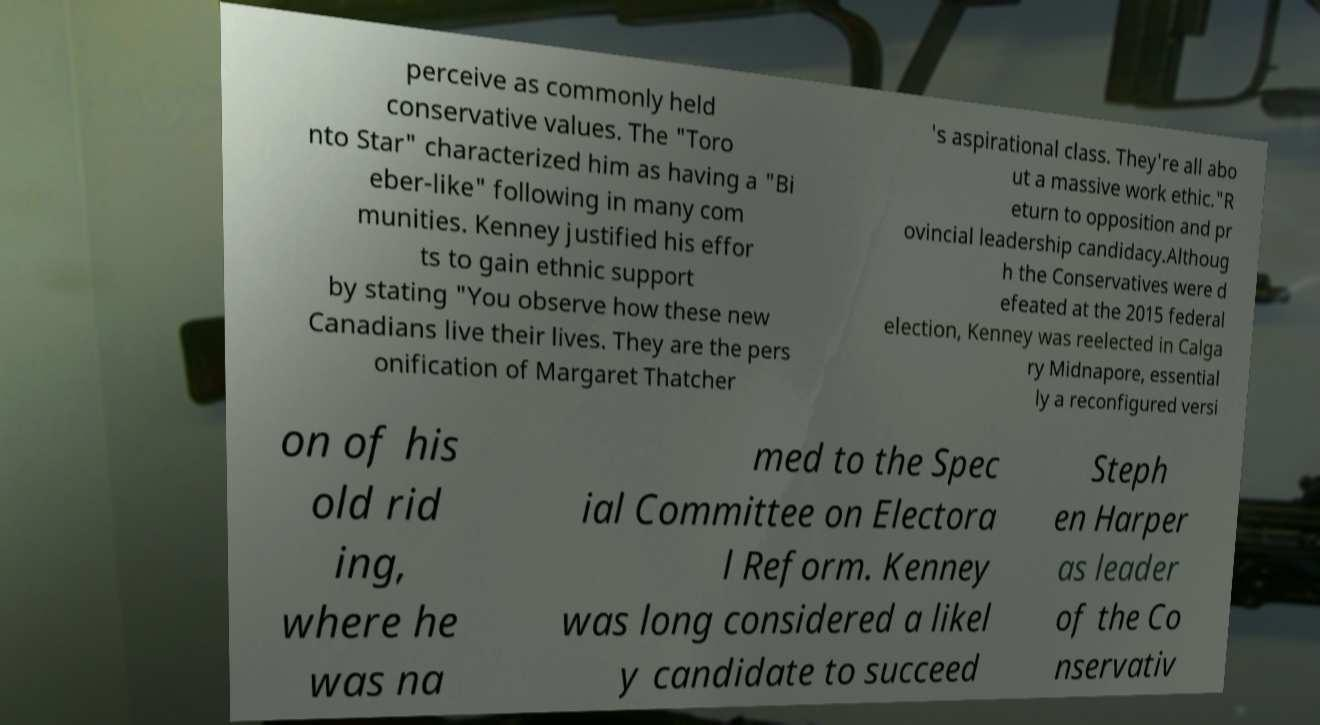There's text embedded in this image that I need extracted. Can you transcribe it verbatim? perceive as commonly held conservative values. The "Toro nto Star" characterized him as having a "Bi eber-like" following in many com munities. Kenney justified his effor ts to gain ethnic support by stating "You observe how these new Canadians live their lives. They are the pers onification of Margaret Thatcher 's aspirational class. They're all abo ut a massive work ethic."R eturn to opposition and pr ovincial leadership candidacy.Althoug h the Conservatives were d efeated at the 2015 federal election, Kenney was reelected in Calga ry Midnapore, essential ly a reconfigured versi on of his old rid ing, where he was na med to the Spec ial Committee on Electora l Reform. Kenney was long considered a likel y candidate to succeed Steph en Harper as leader of the Co nservativ 